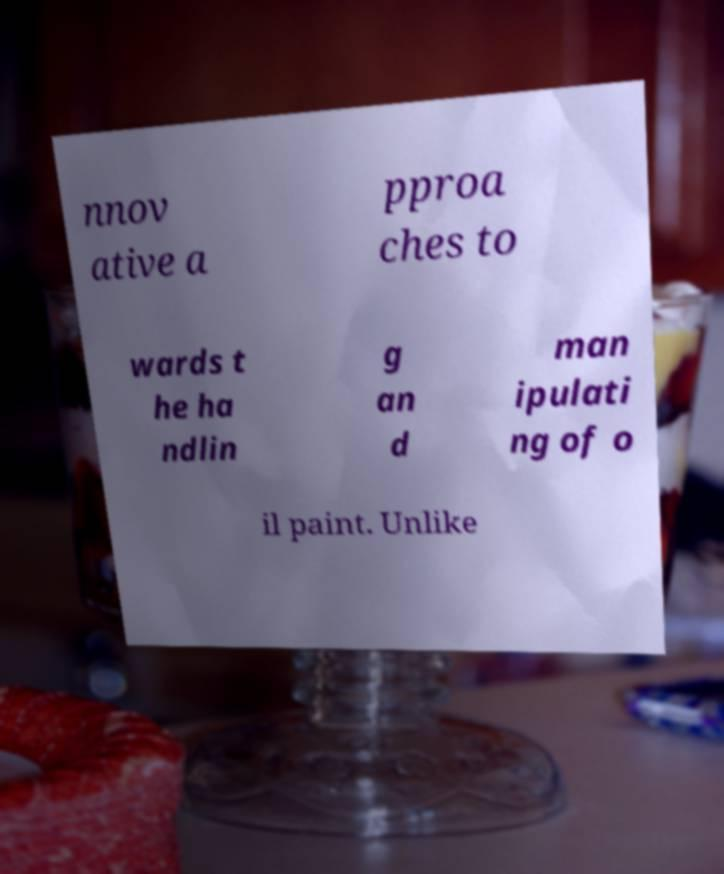There's text embedded in this image that I need extracted. Can you transcribe it verbatim? nnov ative a pproa ches to wards t he ha ndlin g an d man ipulati ng of o il paint. Unlike 